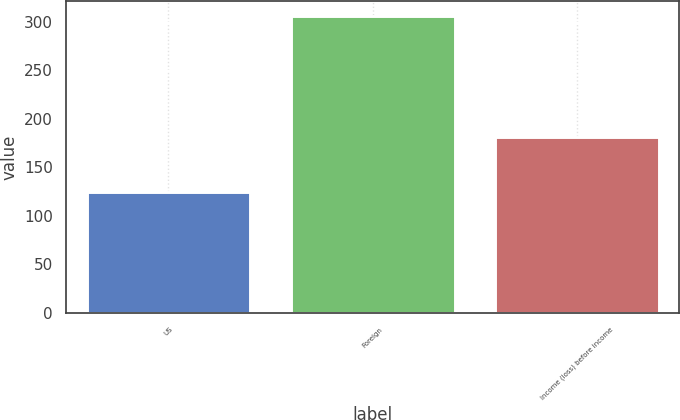Convert chart to OTSL. <chart><loc_0><loc_0><loc_500><loc_500><bar_chart><fcel>US<fcel>Foreign<fcel>Income (loss) before income<nl><fcel>125<fcel>306<fcel>181<nl></chart> 